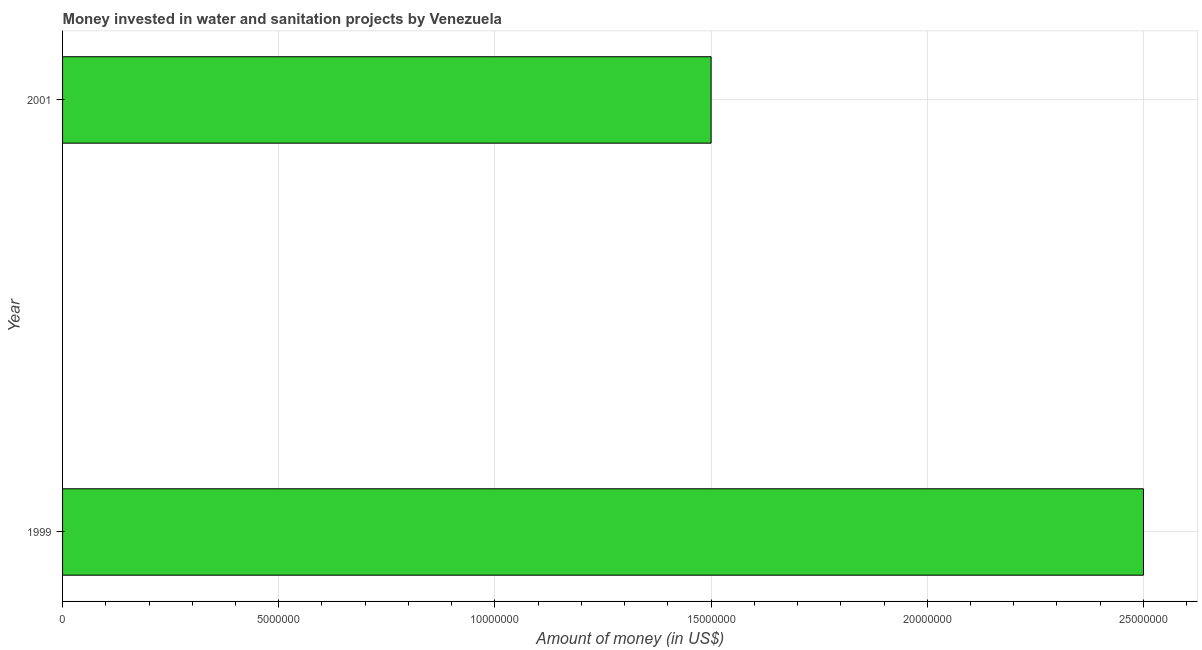Does the graph contain any zero values?
Your answer should be compact. No. Does the graph contain grids?
Your response must be concise. Yes. What is the title of the graph?
Offer a terse response. Money invested in water and sanitation projects by Venezuela. What is the label or title of the X-axis?
Your response must be concise. Amount of money (in US$). What is the label or title of the Y-axis?
Offer a terse response. Year. What is the investment in 1999?
Your response must be concise. 2.50e+07. Across all years, what is the maximum investment?
Your answer should be compact. 2.50e+07. Across all years, what is the minimum investment?
Your response must be concise. 1.50e+07. What is the sum of the investment?
Your response must be concise. 4.00e+07. What is the median investment?
Your response must be concise. 2.00e+07. In how many years, is the investment greater than 12000000 US$?
Offer a very short reply. 2. Do a majority of the years between 1999 and 2001 (inclusive) have investment greater than 25000000 US$?
Offer a terse response. No. What is the ratio of the investment in 1999 to that in 2001?
Provide a short and direct response. 1.67. Is the investment in 1999 less than that in 2001?
Keep it short and to the point. No. How many bars are there?
Provide a short and direct response. 2. Are all the bars in the graph horizontal?
Your response must be concise. Yes. How many years are there in the graph?
Offer a terse response. 2. What is the Amount of money (in US$) of 1999?
Provide a short and direct response. 2.50e+07. What is the Amount of money (in US$) in 2001?
Your answer should be compact. 1.50e+07. What is the difference between the Amount of money (in US$) in 1999 and 2001?
Your response must be concise. 1.00e+07. What is the ratio of the Amount of money (in US$) in 1999 to that in 2001?
Offer a terse response. 1.67. 